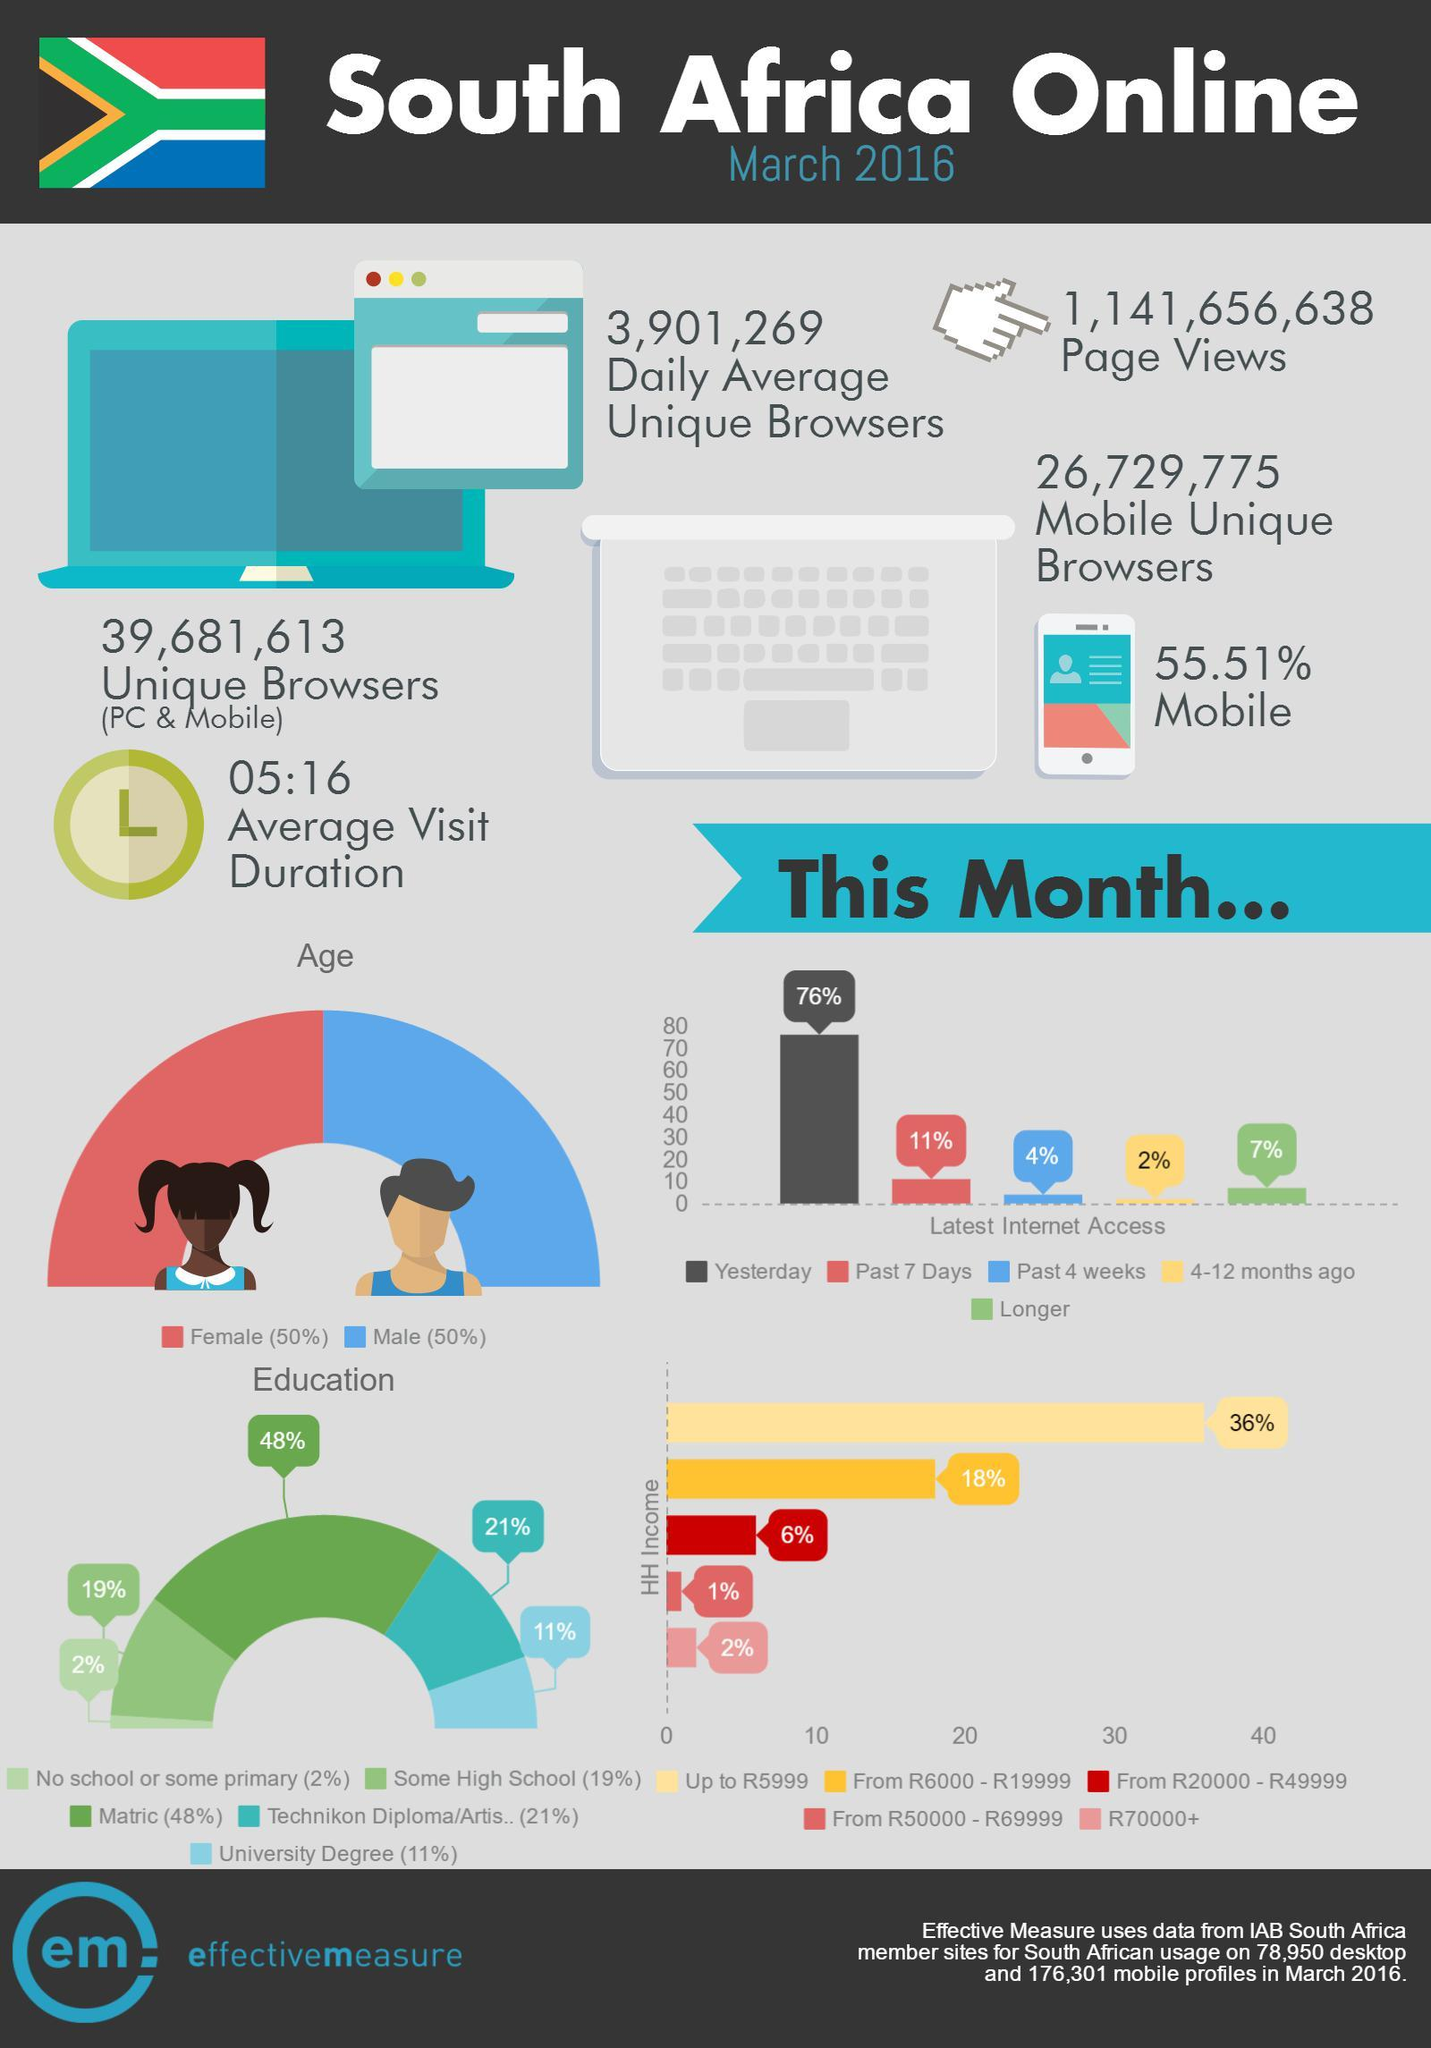Give some essential details in this illustration. During the past four weeks, internet access made up approximately 4% of overall usage. The latest internet access accounted for 76% of the previous day's usage. In the past week, approximately 11% of the population had access to the internet. Approximately 18% of internet users have a household income ranging from R6000 to R19999. According to the survey, only 1% of internet users have a household income within the range of R50,000 to R69,999. 